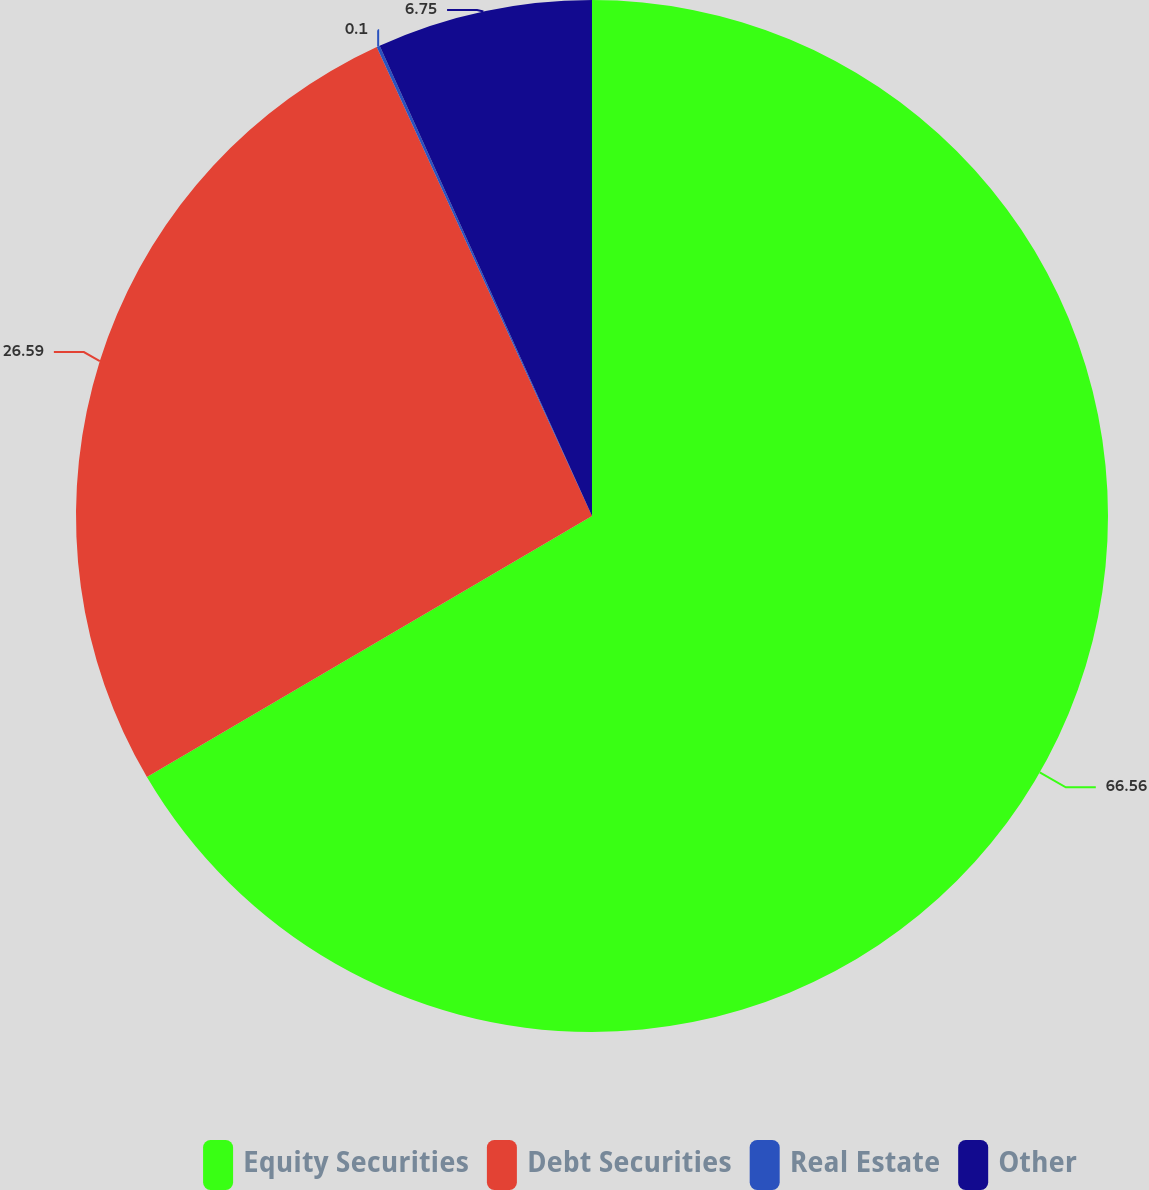<chart> <loc_0><loc_0><loc_500><loc_500><pie_chart><fcel>Equity Securities<fcel>Debt Securities<fcel>Real Estate<fcel>Other<nl><fcel>66.55%<fcel>26.59%<fcel>0.1%<fcel>6.75%<nl></chart> 